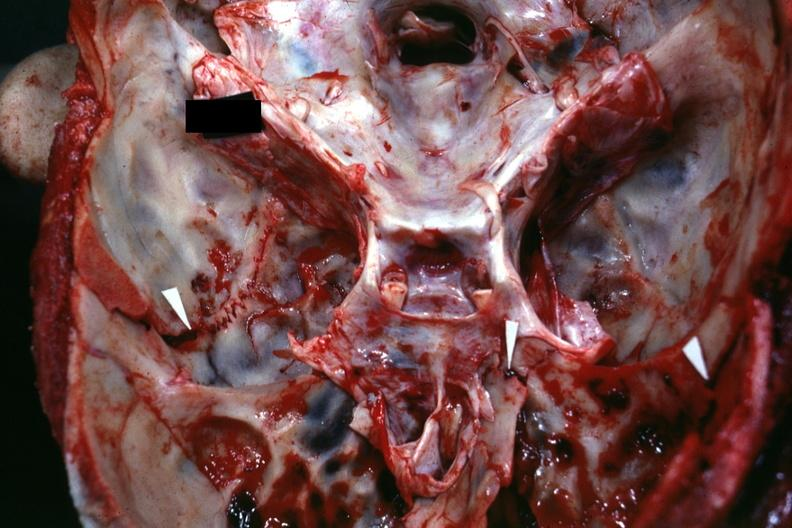how does this image show close-up view of base of skull?
Answer the question using a single word or phrase. With several well shown fractures 